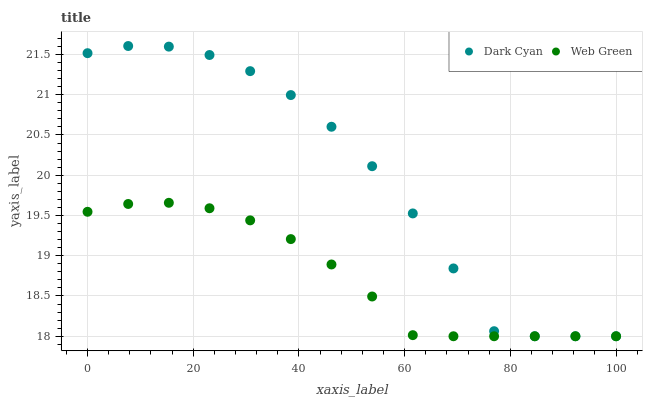Does Web Green have the minimum area under the curve?
Answer yes or no. Yes. Does Dark Cyan have the maximum area under the curve?
Answer yes or no. Yes. Does Web Green have the maximum area under the curve?
Answer yes or no. No. Is Web Green the smoothest?
Answer yes or no. Yes. Is Dark Cyan the roughest?
Answer yes or no. Yes. Is Web Green the roughest?
Answer yes or no. No. Does Dark Cyan have the lowest value?
Answer yes or no. Yes. Does Dark Cyan have the highest value?
Answer yes or no. Yes. Does Web Green have the highest value?
Answer yes or no. No. Does Web Green intersect Dark Cyan?
Answer yes or no. Yes. Is Web Green less than Dark Cyan?
Answer yes or no. No. Is Web Green greater than Dark Cyan?
Answer yes or no. No. 